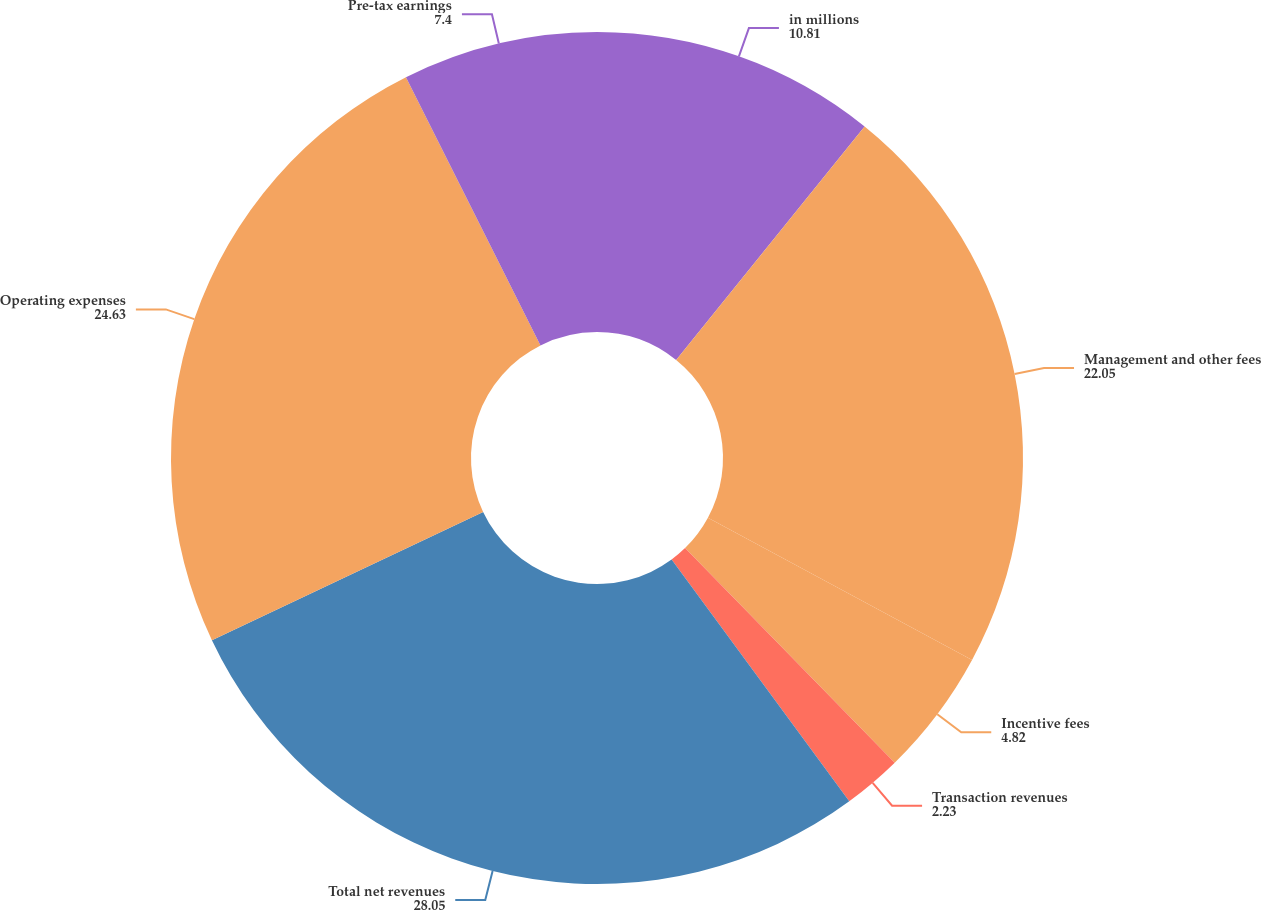<chart> <loc_0><loc_0><loc_500><loc_500><pie_chart><fcel>in millions<fcel>Management and other fees<fcel>Incentive fees<fcel>Transaction revenues<fcel>Total net revenues<fcel>Operating expenses<fcel>Pre-tax earnings<nl><fcel>10.81%<fcel>22.05%<fcel>4.82%<fcel>2.23%<fcel>28.05%<fcel>24.63%<fcel>7.4%<nl></chart> 